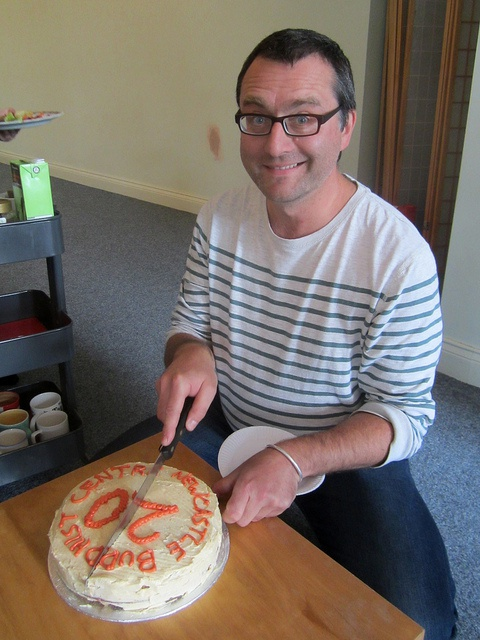Describe the objects in this image and their specific colors. I can see people in olive, darkgray, black, gray, and brown tones, dining table in olive, brown, gray, lightgray, and maroon tones, cake in olive, ivory, and tan tones, knife in olive, gray, black, and brown tones, and cup in olive, gray, and black tones in this image. 